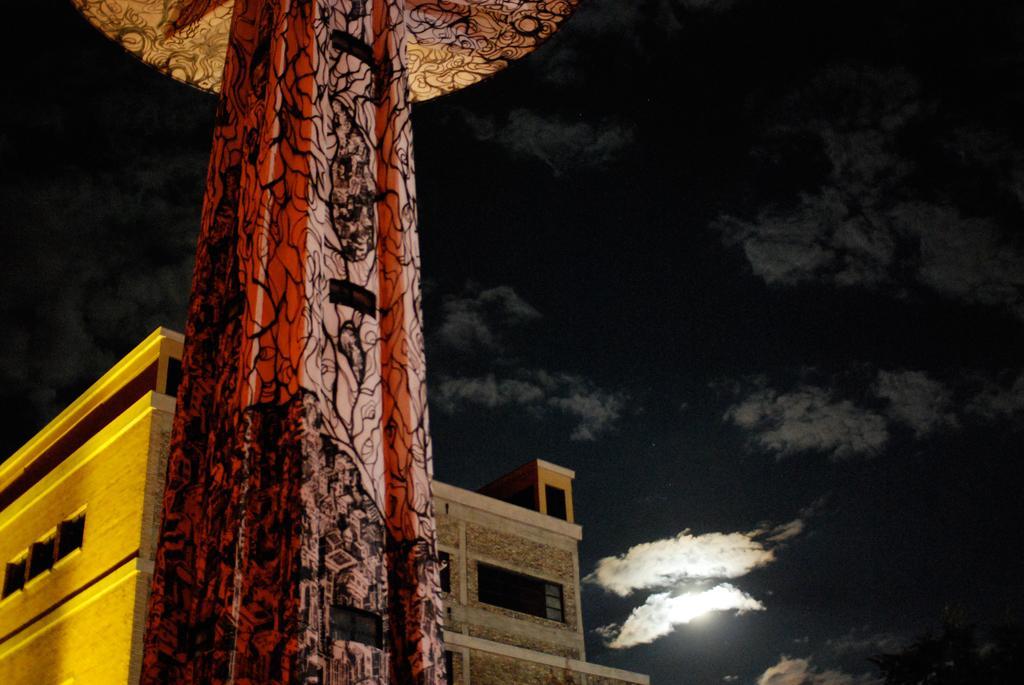Describe this image in one or two sentences. In this image we can see a pillar, behind the pillar we can see a building, at the top of the image there are clouds in the sky. 